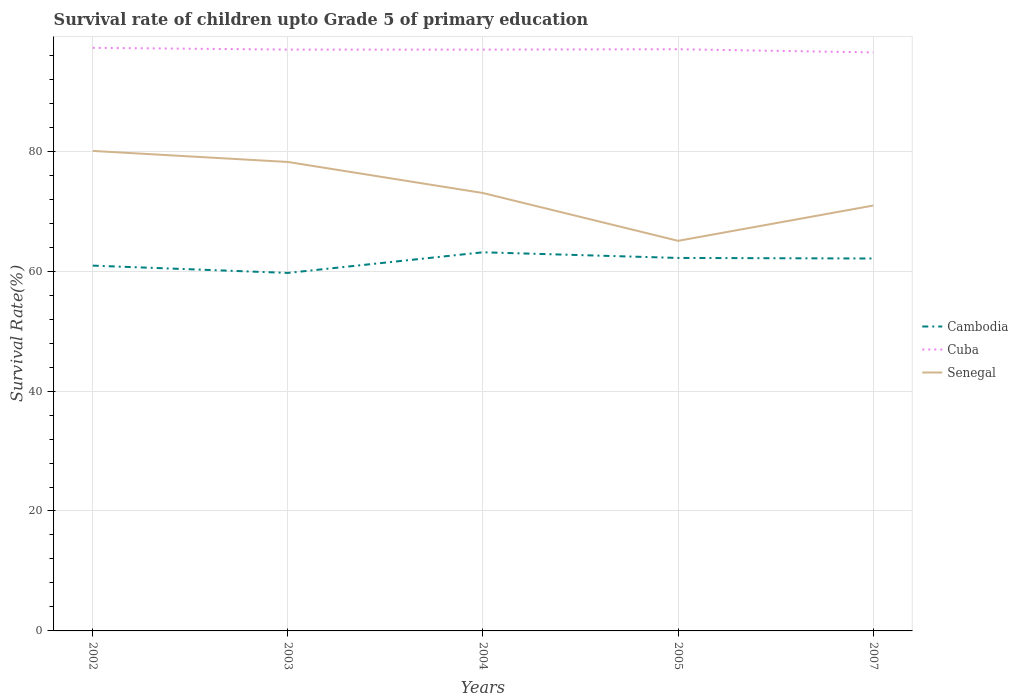How many different coloured lines are there?
Make the answer very short. 3. Does the line corresponding to Cuba intersect with the line corresponding to Cambodia?
Your answer should be very brief. No. Is the number of lines equal to the number of legend labels?
Provide a short and direct response. Yes. Across all years, what is the maximum survival rate of children in Senegal?
Provide a succinct answer. 65.05. In which year was the survival rate of children in Cuba maximum?
Give a very brief answer. 2007. What is the total survival rate of children in Cambodia in the graph?
Ensure brevity in your answer.  1.04. What is the difference between the highest and the second highest survival rate of children in Cambodia?
Your answer should be very brief. 3.44. How many years are there in the graph?
Make the answer very short. 5. What is the difference between two consecutive major ticks on the Y-axis?
Your answer should be compact. 20. How are the legend labels stacked?
Your answer should be very brief. Vertical. What is the title of the graph?
Give a very brief answer. Survival rate of children upto Grade 5 of primary education. Does "Curacao" appear as one of the legend labels in the graph?
Make the answer very short. No. What is the label or title of the Y-axis?
Give a very brief answer. Survival Rate(%). What is the Survival Rate(%) of Cambodia in 2002?
Your response must be concise. 60.92. What is the Survival Rate(%) in Cuba in 2002?
Your answer should be very brief. 97.24. What is the Survival Rate(%) in Senegal in 2002?
Provide a short and direct response. 80.04. What is the Survival Rate(%) of Cambodia in 2003?
Provide a succinct answer. 59.7. What is the Survival Rate(%) of Cuba in 2003?
Your answer should be compact. 96.94. What is the Survival Rate(%) of Senegal in 2003?
Provide a short and direct response. 78.2. What is the Survival Rate(%) of Cambodia in 2004?
Offer a very short reply. 63.14. What is the Survival Rate(%) of Cuba in 2004?
Offer a very short reply. 96.94. What is the Survival Rate(%) in Senegal in 2004?
Your answer should be very brief. 73.02. What is the Survival Rate(%) in Cambodia in 2005?
Provide a succinct answer. 62.2. What is the Survival Rate(%) in Cuba in 2005?
Give a very brief answer. 97. What is the Survival Rate(%) of Senegal in 2005?
Ensure brevity in your answer.  65.05. What is the Survival Rate(%) of Cambodia in 2007?
Give a very brief answer. 62.1. What is the Survival Rate(%) of Cuba in 2007?
Keep it short and to the point. 96.47. What is the Survival Rate(%) in Senegal in 2007?
Offer a terse response. 70.94. Across all years, what is the maximum Survival Rate(%) in Cambodia?
Ensure brevity in your answer.  63.14. Across all years, what is the maximum Survival Rate(%) in Cuba?
Your answer should be compact. 97.24. Across all years, what is the maximum Survival Rate(%) of Senegal?
Provide a succinct answer. 80.04. Across all years, what is the minimum Survival Rate(%) of Cambodia?
Your response must be concise. 59.7. Across all years, what is the minimum Survival Rate(%) in Cuba?
Your answer should be compact. 96.47. Across all years, what is the minimum Survival Rate(%) in Senegal?
Offer a very short reply. 65.05. What is the total Survival Rate(%) of Cambodia in the graph?
Your answer should be very brief. 308.06. What is the total Survival Rate(%) of Cuba in the graph?
Give a very brief answer. 484.59. What is the total Survival Rate(%) in Senegal in the graph?
Offer a very short reply. 367.26. What is the difference between the Survival Rate(%) of Cambodia in 2002 and that in 2003?
Provide a succinct answer. 1.22. What is the difference between the Survival Rate(%) in Cuba in 2002 and that in 2003?
Your answer should be compact. 0.29. What is the difference between the Survival Rate(%) of Senegal in 2002 and that in 2003?
Keep it short and to the point. 1.84. What is the difference between the Survival Rate(%) in Cambodia in 2002 and that in 2004?
Your answer should be compact. -2.23. What is the difference between the Survival Rate(%) in Cuba in 2002 and that in 2004?
Your answer should be very brief. 0.3. What is the difference between the Survival Rate(%) in Senegal in 2002 and that in 2004?
Your answer should be very brief. 7.02. What is the difference between the Survival Rate(%) in Cambodia in 2002 and that in 2005?
Ensure brevity in your answer.  -1.28. What is the difference between the Survival Rate(%) in Cuba in 2002 and that in 2005?
Provide a short and direct response. 0.23. What is the difference between the Survival Rate(%) of Senegal in 2002 and that in 2005?
Your answer should be very brief. 14.99. What is the difference between the Survival Rate(%) in Cambodia in 2002 and that in 2007?
Keep it short and to the point. -1.19. What is the difference between the Survival Rate(%) of Cuba in 2002 and that in 2007?
Your answer should be compact. 0.77. What is the difference between the Survival Rate(%) in Senegal in 2002 and that in 2007?
Provide a short and direct response. 9.11. What is the difference between the Survival Rate(%) in Cambodia in 2003 and that in 2004?
Keep it short and to the point. -3.44. What is the difference between the Survival Rate(%) of Cuba in 2003 and that in 2004?
Ensure brevity in your answer.  0.01. What is the difference between the Survival Rate(%) in Senegal in 2003 and that in 2004?
Provide a succinct answer. 5.18. What is the difference between the Survival Rate(%) in Cambodia in 2003 and that in 2005?
Your response must be concise. -2.5. What is the difference between the Survival Rate(%) of Cuba in 2003 and that in 2005?
Provide a short and direct response. -0.06. What is the difference between the Survival Rate(%) in Senegal in 2003 and that in 2005?
Offer a very short reply. 13.15. What is the difference between the Survival Rate(%) in Cambodia in 2003 and that in 2007?
Make the answer very short. -2.4. What is the difference between the Survival Rate(%) of Cuba in 2003 and that in 2007?
Your answer should be compact. 0.47. What is the difference between the Survival Rate(%) of Senegal in 2003 and that in 2007?
Offer a very short reply. 7.27. What is the difference between the Survival Rate(%) of Cambodia in 2004 and that in 2005?
Your answer should be very brief. 0.94. What is the difference between the Survival Rate(%) in Cuba in 2004 and that in 2005?
Your response must be concise. -0.06. What is the difference between the Survival Rate(%) of Senegal in 2004 and that in 2005?
Your answer should be compact. 7.97. What is the difference between the Survival Rate(%) in Cambodia in 2004 and that in 2007?
Offer a terse response. 1.04. What is the difference between the Survival Rate(%) in Cuba in 2004 and that in 2007?
Your answer should be compact. 0.47. What is the difference between the Survival Rate(%) of Senegal in 2004 and that in 2007?
Ensure brevity in your answer.  2.09. What is the difference between the Survival Rate(%) in Cambodia in 2005 and that in 2007?
Provide a short and direct response. 0.1. What is the difference between the Survival Rate(%) of Cuba in 2005 and that in 2007?
Ensure brevity in your answer.  0.53. What is the difference between the Survival Rate(%) in Senegal in 2005 and that in 2007?
Your answer should be very brief. -5.89. What is the difference between the Survival Rate(%) of Cambodia in 2002 and the Survival Rate(%) of Cuba in 2003?
Your response must be concise. -36.03. What is the difference between the Survival Rate(%) of Cambodia in 2002 and the Survival Rate(%) of Senegal in 2003?
Ensure brevity in your answer.  -17.29. What is the difference between the Survival Rate(%) of Cuba in 2002 and the Survival Rate(%) of Senegal in 2003?
Offer a terse response. 19.03. What is the difference between the Survival Rate(%) of Cambodia in 2002 and the Survival Rate(%) of Cuba in 2004?
Your answer should be very brief. -36.02. What is the difference between the Survival Rate(%) in Cambodia in 2002 and the Survival Rate(%) in Senegal in 2004?
Provide a succinct answer. -12.11. What is the difference between the Survival Rate(%) of Cuba in 2002 and the Survival Rate(%) of Senegal in 2004?
Keep it short and to the point. 24.21. What is the difference between the Survival Rate(%) in Cambodia in 2002 and the Survival Rate(%) in Cuba in 2005?
Give a very brief answer. -36.08. What is the difference between the Survival Rate(%) in Cambodia in 2002 and the Survival Rate(%) in Senegal in 2005?
Your answer should be very brief. -4.14. What is the difference between the Survival Rate(%) of Cuba in 2002 and the Survival Rate(%) of Senegal in 2005?
Offer a terse response. 32.18. What is the difference between the Survival Rate(%) in Cambodia in 2002 and the Survival Rate(%) in Cuba in 2007?
Your answer should be very brief. -35.55. What is the difference between the Survival Rate(%) of Cambodia in 2002 and the Survival Rate(%) of Senegal in 2007?
Offer a very short reply. -10.02. What is the difference between the Survival Rate(%) of Cuba in 2002 and the Survival Rate(%) of Senegal in 2007?
Make the answer very short. 26.3. What is the difference between the Survival Rate(%) of Cambodia in 2003 and the Survival Rate(%) of Cuba in 2004?
Your answer should be compact. -37.24. What is the difference between the Survival Rate(%) in Cambodia in 2003 and the Survival Rate(%) in Senegal in 2004?
Offer a terse response. -13.32. What is the difference between the Survival Rate(%) of Cuba in 2003 and the Survival Rate(%) of Senegal in 2004?
Provide a succinct answer. 23.92. What is the difference between the Survival Rate(%) in Cambodia in 2003 and the Survival Rate(%) in Cuba in 2005?
Offer a very short reply. -37.3. What is the difference between the Survival Rate(%) of Cambodia in 2003 and the Survival Rate(%) of Senegal in 2005?
Your answer should be compact. -5.35. What is the difference between the Survival Rate(%) in Cuba in 2003 and the Survival Rate(%) in Senegal in 2005?
Your answer should be compact. 31.89. What is the difference between the Survival Rate(%) in Cambodia in 2003 and the Survival Rate(%) in Cuba in 2007?
Give a very brief answer. -36.77. What is the difference between the Survival Rate(%) in Cambodia in 2003 and the Survival Rate(%) in Senegal in 2007?
Provide a succinct answer. -11.24. What is the difference between the Survival Rate(%) of Cuba in 2003 and the Survival Rate(%) of Senegal in 2007?
Ensure brevity in your answer.  26.01. What is the difference between the Survival Rate(%) of Cambodia in 2004 and the Survival Rate(%) of Cuba in 2005?
Provide a succinct answer. -33.86. What is the difference between the Survival Rate(%) in Cambodia in 2004 and the Survival Rate(%) in Senegal in 2005?
Your answer should be compact. -1.91. What is the difference between the Survival Rate(%) of Cuba in 2004 and the Survival Rate(%) of Senegal in 2005?
Offer a terse response. 31.89. What is the difference between the Survival Rate(%) in Cambodia in 2004 and the Survival Rate(%) in Cuba in 2007?
Ensure brevity in your answer.  -33.33. What is the difference between the Survival Rate(%) of Cambodia in 2004 and the Survival Rate(%) of Senegal in 2007?
Your answer should be compact. -7.8. What is the difference between the Survival Rate(%) of Cuba in 2004 and the Survival Rate(%) of Senegal in 2007?
Your response must be concise. 26. What is the difference between the Survival Rate(%) of Cambodia in 2005 and the Survival Rate(%) of Cuba in 2007?
Your answer should be very brief. -34.27. What is the difference between the Survival Rate(%) of Cambodia in 2005 and the Survival Rate(%) of Senegal in 2007?
Your answer should be very brief. -8.74. What is the difference between the Survival Rate(%) in Cuba in 2005 and the Survival Rate(%) in Senegal in 2007?
Keep it short and to the point. 26.06. What is the average Survival Rate(%) in Cambodia per year?
Your answer should be very brief. 61.61. What is the average Survival Rate(%) of Cuba per year?
Offer a very short reply. 96.92. What is the average Survival Rate(%) in Senegal per year?
Keep it short and to the point. 73.45. In the year 2002, what is the difference between the Survival Rate(%) in Cambodia and Survival Rate(%) in Cuba?
Offer a very short reply. -36.32. In the year 2002, what is the difference between the Survival Rate(%) of Cambodia and Survival Rate(%) of Senegal?
Make the answer very short. -19.13. In the year 2002, what is the difference between the Survival Rate(%) in Cuba and Survival Rate(%) in Senegal?
Provide a succinct answer. 17.19. In the year 2003, what is the difference between the Survival Rate(%) in Cambodia and Survival Rate(%) in Cuba?
Your answer should be compact. -37.24. In the year 2003, what is the difference between the Survival Rate(%) in Cambodia and Survival Rate(%) in Senegal?
Keep it short and to the point. -18.5. In the year 2003, what is the difference between the Survival Rate(%) of Cuba and Survival Rate(%) of Senegal?
Provide a succinct answer. 18.74. In the year 2004, what is the difference between the Survival Rate(%) of Cambodia and Survival Rate(%) of Cuba?
Give a very brief answer. -33.8. In the year 2004, what is the difference between the Survival Rate(%) of Cambodia and Survival Rate(%) of Senegal?
Provide a short and direct response. -9.88. In the year 2004, what is the difference between the Survival Rate(%) in Cuba and Survival Rate(%) in Senegal?
Give a very brief answer. 23.91. In the year 2005, what is the difference between the Survival Rate(%) of Cambodia and Survival Rate(%) of Cuba?
Your answer should be compact. -34.8. In the year 2005, what is the difference between the Survival Rate(%) in Cambodia and Survival Rate(%) in Senegal?
Give a very brief answer. -2.85. In the year 2005, what is the difference between the Survival Rate(%) in Cuba and Survival Rate(%) in Senegal?
Provide a succinct answer. 31.95. In the year 2007, what is the difference between the Survival Rate(%) in Cambodia and Survival Rate(%) in Cuba?
Give a very brief answer. -34.37. In the year 2007, what is the difference between the Survival Rate(%) in Cambodia and Survival Rate(%) in Senegal?
Provide a succinct answer. -8.84. In the year 2007, what is the difference between the Survival Rate(%) of Cuba and Survival Rate(%) of Senegal?
Your answer should be very brief. 25.53. What is the ratio of the Survival Rate(%) of Cambodia in 2002 to that in 2003?
Your response must be concise. 1.02. What is the ratio of the Survival Rate(%) in Cuba in 2002 to that in 2003?
Provide a short and direct response. 1. What is the ratio of the Survival Rate(%) of Senegal in 2002 to that in 2003?
Give a very brief answer. 1.02. What is the ratio of the Survival Rate(%) of Cambodia in 2002 to that in 2004?
Ensure brevity in your answer.  0.96. What is the ratio of the Survival Rate(%) of Cuba in 2002 to that in 2004?
Provide a short and direct response. 1. What is the ratio of the Survival Rate(%) of Senegal in 2002 to that in 2004?
Offer a terse response. 1.1. What is the ratio of the Survival Rate(%) in Cambodia in 2002 to that in 2005?
Provide a succinct answer. 0.98. What is the ratio of the Survival Rate(%) in Senegal in 2002 to that in 2005?
Your answer should be compact. 1.23. What is the ratio of the Survival Rate(%) of Cambodia in 2002 to that in 2007?
Your answer should be compact. 0.98. What is the ratio of the Survival Rate(%) of Cuba in 2002 to that in 2007?
Make the answer very short. 1.01. What is the ratio of the Survival Rate(%) of Senegal in 2002 to that in 2007?
Ensure brevity in your answer.  1.13. What is the ratio of the Survival Rate(%) of Cambodia in 2003 to that in 2004?
Your answer should be compact. 0.95. What is the ratio of the Survival Rate(%) in Senegal in 2003 to that in 2004?
Offer a very short reply. 1.07. What is the ratio of the Survival Rate(%) of Cambodia in 2003 to that in 2005?
Give a very brief answer. 0.96. What is the ratio of the Survival Rate(%) in Cuba in 2003 to that in 2005?
Offer a terse response. 1. What is the ratio of the Survival Rate(%) in Senegal in 2003 to that in 2005?
Offer a very short reply. 1.2. What is the ratio of the Survival Rate(%) of Cambodia in 2003 to that in 2007?
Provide a short and direct response. 0.96. What is the ratio of the Survival Rate(%) in Cuba in 2003 to that in 2007?
Your response must be concise. 1. What is the ratio of the Survival Rate(%) of Senegal in 2003 to that in 2007?
Provide a succinct answer. 1.1. What is the ratio of the Survival Rate(%) of Cambodia in 2004 to that in 2005?
Offer a terse response. 1.02. What is the ratio of the Survival Rate(%) in Senegal in 2004 to that in 2005?
Ensure brevity in your answer.  1.12. What is the ratio of the Survival Rate(%) in Cambodia in 2004 to that in 2007?
Offer a very short reply. 1.02. What is the ratio of the Survival Rate(%) in Cuba in 2004 to that in 2007?
Give a very brief answer. 1. What is the ratio of the Survival Rate(%) of Senegal in 2004 to that in 2007?
Your response must be concise. 1.03. What is the ratio of the Survival Rate(%) in Cambodia in 2005 to that in 2007?
Your response must be concise. 1. What is the ratio of the Survival Rate(%) in Cuba in 2005 to that in 2007?
Provide a short and direct response. 1.01. What is the ratio of the Survival Rate(%) in Senegal in 2005 to that in 2007?
Make the answer very short. 0.92. What is the difference between the highest and the second highest Survival Rate(%) in Cambodia?
Your answer should be compact. 0.94. What is the difference between the highest and the second highest Survival Rate(%) in Cuba?
Keep it short and to the point. 0.23. What is the difference between the highest and the second highest Survival Rate(%) of Senegal?
Ensure brevity in your answer.  1.84. What is the difference between the highest and the lowest Survival Rate(%) of Cambodia?
Give a very brief answer. 3.44. What is the difference between the highest and the lowest Survival Rate(%) of Cuba?
Keep it short and to the point. 0.77. What is the difference between the highest and the lowest Survival Rate(%) of Senegal?
Your answer should be compact. 14.99. 